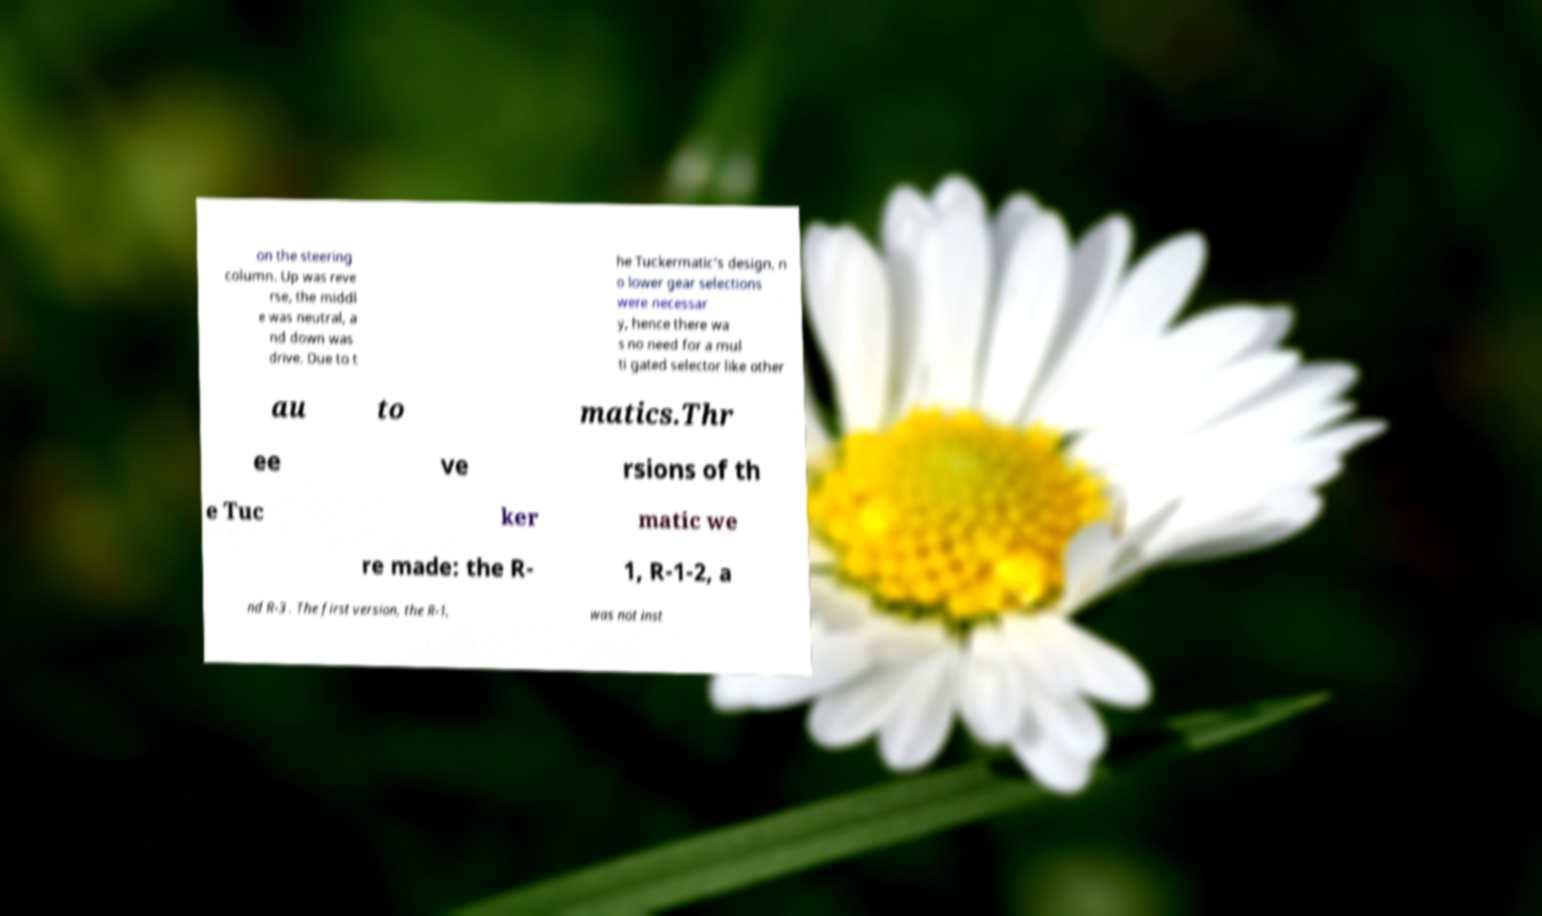Please identify and transcribe the text found in this image. on the steering column. Up was reve rse, the middl e was neutral, a nd down was drive. Due to t he Tuckermatic's design, n o lower gear selections were necessar y, hence there wa s no need for a mul ti gated selector like other au to matics.Thr ee ve rsions of th e Tuc ker matic we re made: the R- 1, R-1-2, a nd R-3 . The first version, the R-1, was not inst 